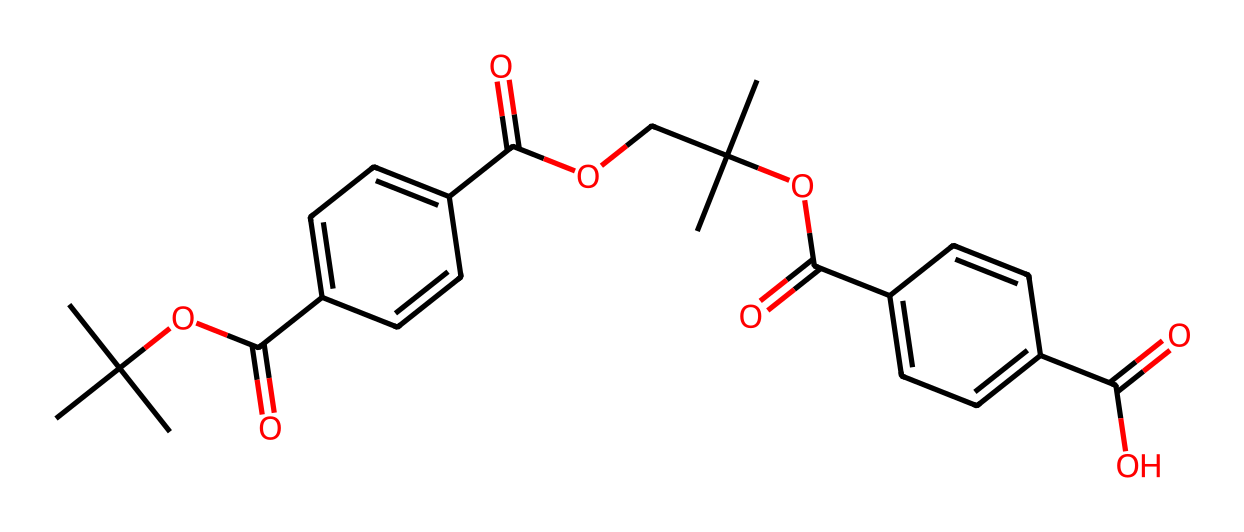What is the main functional group present in this chemical? The chemical has multiple ester groups, identifiable by the carbonyl (C=O) adjacent to an oxygen atom (–O), which is characteristic of esters.
Answer: ester How many benzene rings are in the structure? The structure contains two distinct aromatic rings, which can be identified by the presence of the six-membered carbon rings with alternating double bonds.
Answer: 2 What atoms are primarily responsible for the solubility of this compound in organic solvents? The presence of ester functional groups contributes to its solubility in organic solvents. These groups can interact favorably with similar solvent molecules, allowing for dissolution.
Answer: ester groups What is the total number of carbon atoms in this molecule? By counting each carbon atom in the structure, including those present in functional groups and rings, we find a total of 22 carbon atoms.
Answer: 22 How many oxygen atoms are present in the structure? The structure includes several ester linkages and hydroxyl groups; by counting, there are a total of 6 oxygen atoms in the molecule.
Answer: 6 What type of polymer does this chemical represent? This chemical is a polyester due to the recurring ester linkages formed from the combination of terphthalic acid and alcohol, which is characteristic of polyesters.
Answer: polyester 